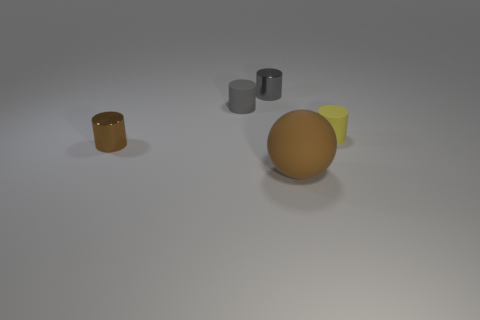Subtract all yellow cylinders. How many cylinders are left? 3 Subtract all red spheres. How many gray cylinders are left? 2 Subtract all brown cylinders. How many cylinders are left? 3 Subtract 2 cylinders. How many cylinders are left? 2 Add 3 small red rubber cylinders. How many objects exist? 8 Subtract all red cylinders. Subtract all purple balls. How many cylinders are left? 4 Subtract all spheres. How many objects are left? 4 Subtract all big rubber balls. Subtract all large gray rubber balls. How many objects are left? 4 Add 2 tiny brown metallic cylinders. How many tiny brown metallic cylinders are left? 3 Add 2 tiny objects. How many tiny objects exist? 6 